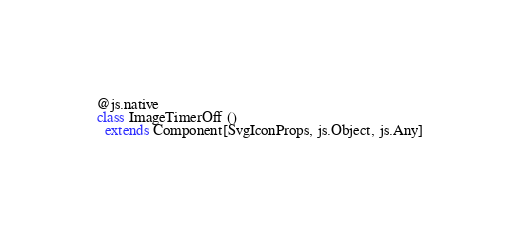<code> <loc_0><loc_0><loc_500><loc_500><_Scala_>@js.native
class ImageTimerOff ()
  extends Component[SvgIconProps, js.Object, js.Any]
</code> 